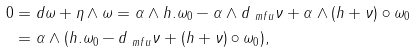<formula> <loc_0><loc_0><loc_500><loc_500>0 & = d \omega + \eta \wedge \omega = \alpha \wedge h . \omega _ { 0 } - \alpha \wedge d _ { \ m f u } \nu + \alpha \wedge ( h + \nu ) \circ \omega _ { 0 } \\ & = \alpha \wedge ( h . \omega _ { 0 } - d _ { \ m f u } \nu + ( h + \nu ) \circ \omega _ { 0 } ) ,</formula> 